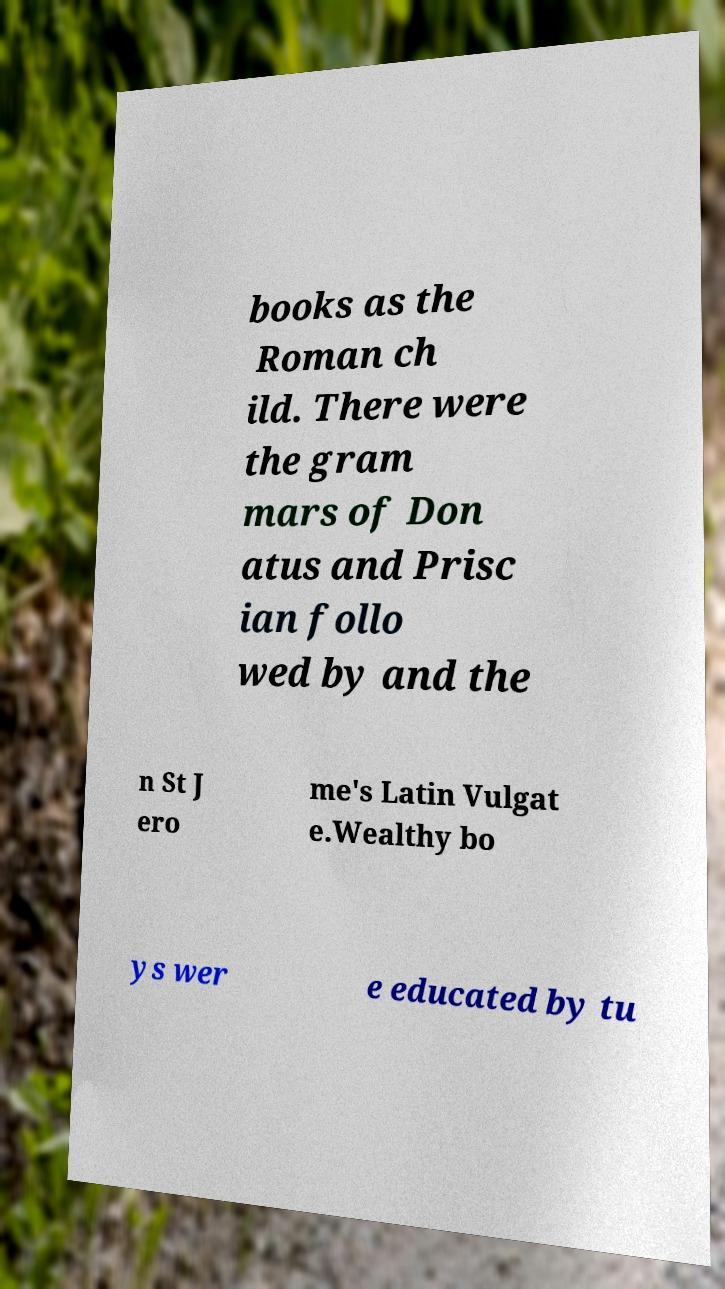What messages or text are displayed in this image? I need them in a readable, typed format. books as the Roman ch ild. There were the gram mars of Don atus and Prisc ian follo wed by and the n St J ero me's Latin Vulgat e.Wealthy bo ys wer e educated by tu 